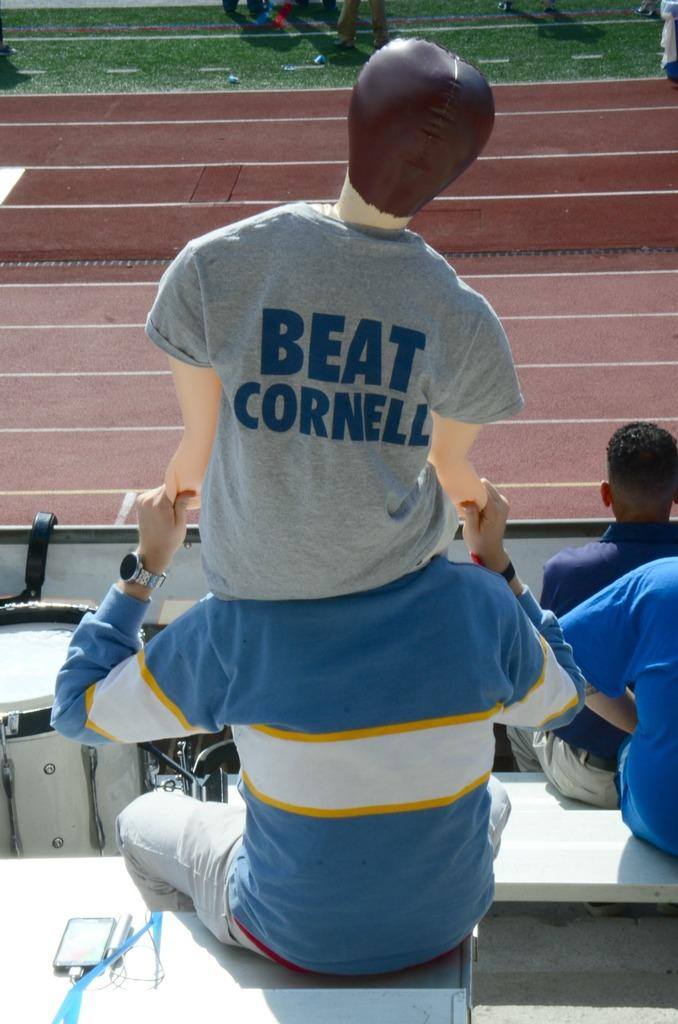<image>
Present a compact description of the photo's key features. the name beat cornell that is on a shirt 